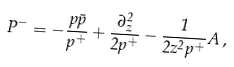<formula> <loc_0><loc_0><loc_500><loc_500>P ^ { - } = - \frac { p \bar { p } } { p ^ { + } } + \frac { \partial ^ { 2 } _ { z } } { 2 p ^ { + } } - \frac { 1 } { 2 z ^ { 2 } p ^ { + } } A \, ,</formula> 